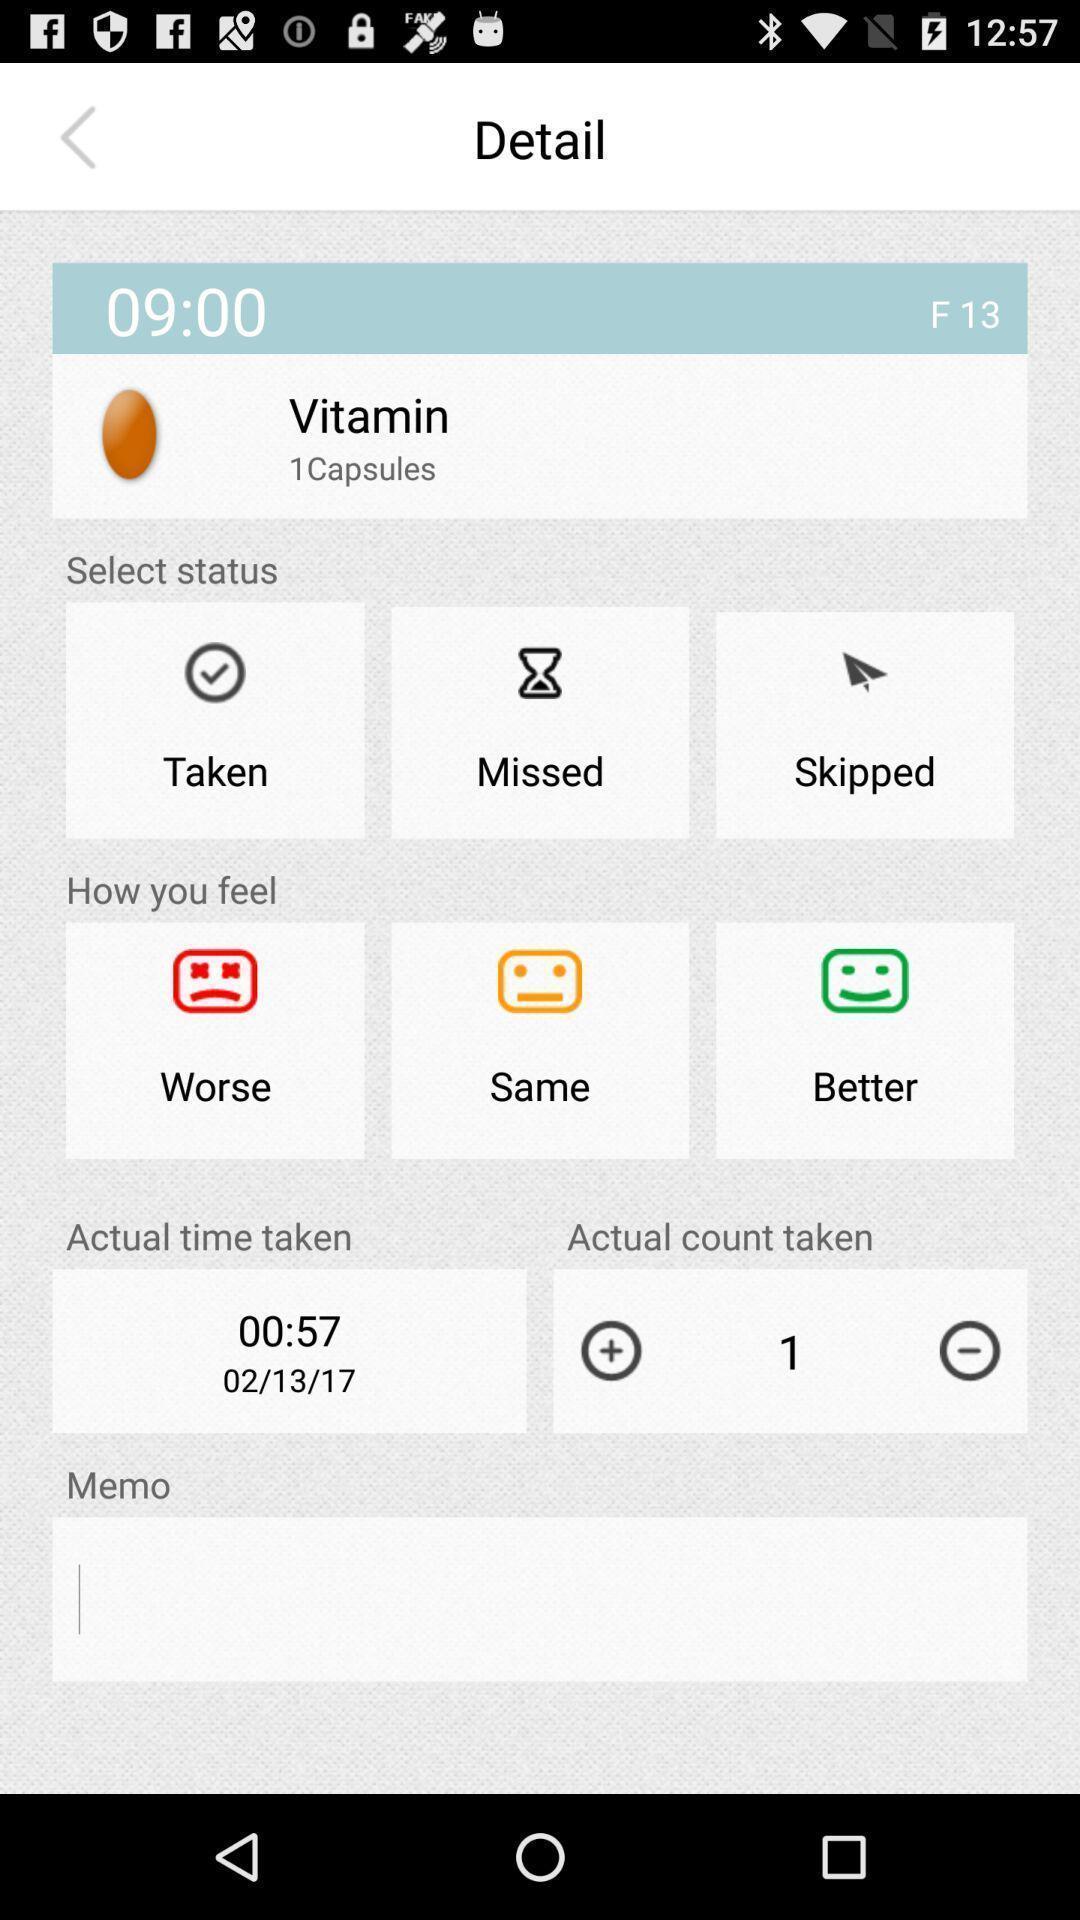What can you discern from this picture? Screen page of a healthcare app. 